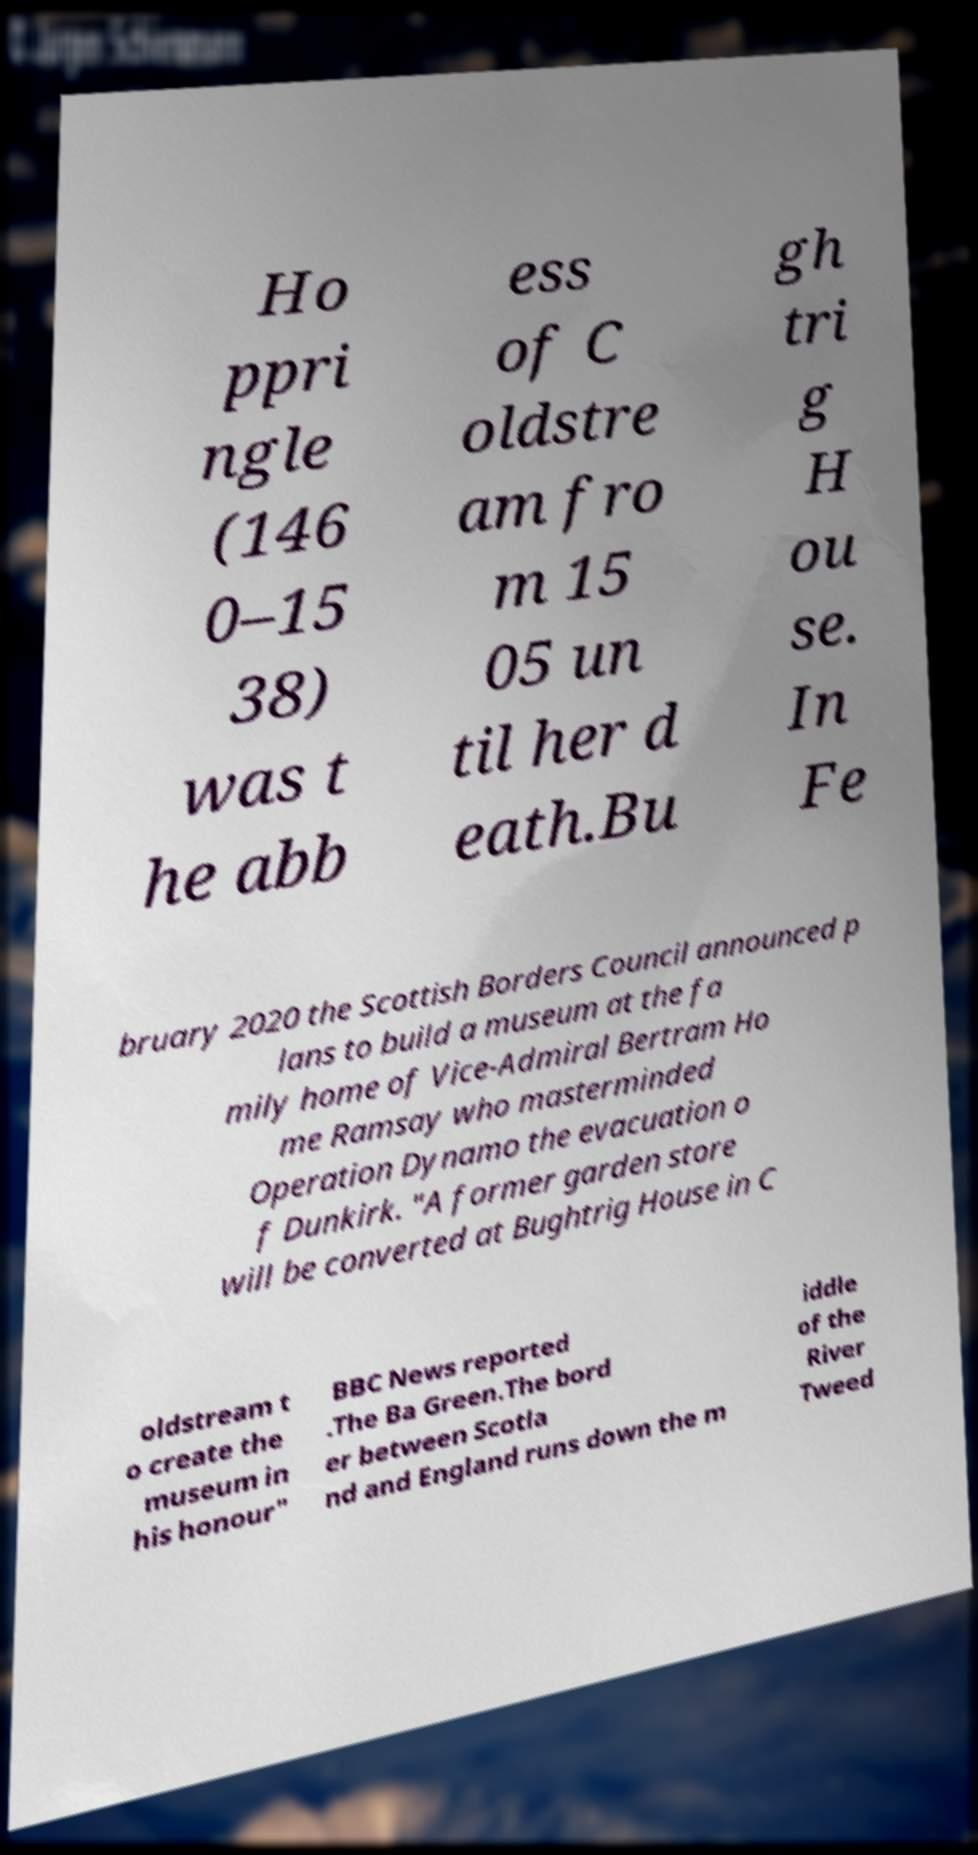Please read and relay the text visible in this image. What does it say? Ho ppri ngle (146 0–15 38) was t he abb ess of C oldstre am fro m 15 05 un til her d eath.Bu gh tri g H ou se. In Fe bruary 2020 the Scottish Borders Council announced p lans to build a museum at the fa mily home of Vice-Admiral Bertram Ho me Ramsay who masterminded Operation Dynamo the evacuation o f Dunkirk. "A former garden store will be converted at Bughtrig House in C oldstream t o create the museum in his honour" BBC News reported .The Ba Green.The bord er between Scotla nd and England runs down the m iddle of the River Tweed 